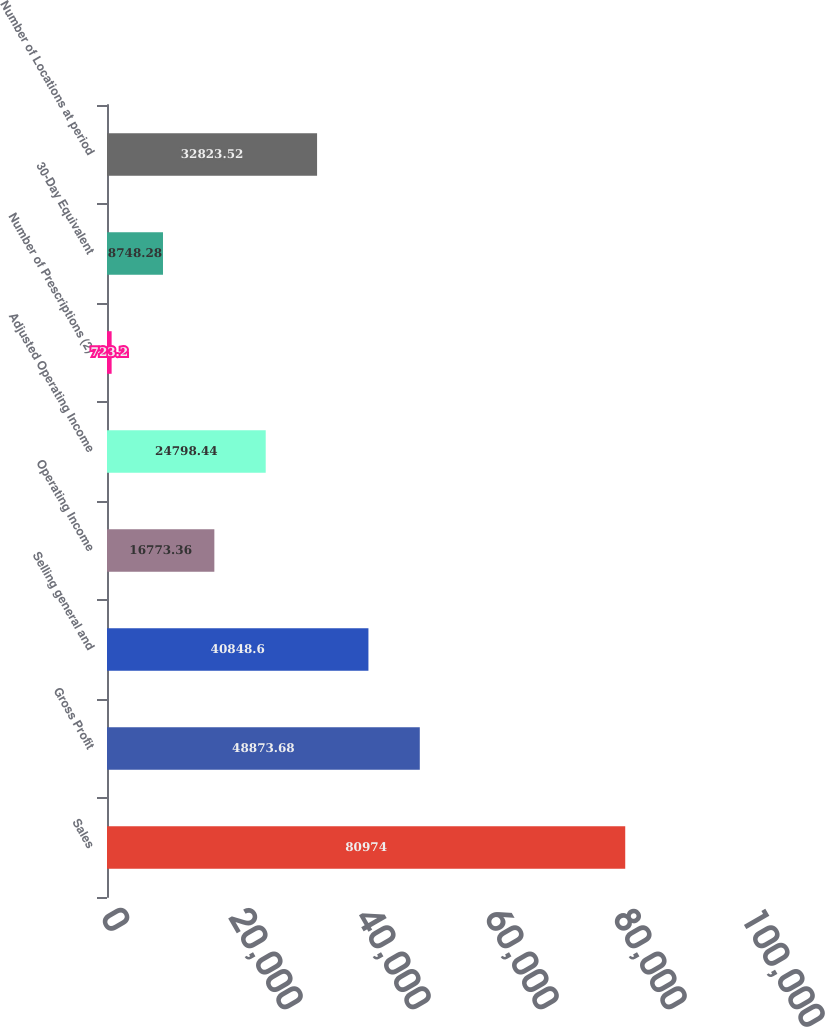Convert chart to OTSL. <chart><loc_0><loc_0><loc_500><loc_500><bar_chart><fcel>Sales<fcel>Gross Profit<fcel>Selling general and<fcel>Operating Income<fcel>Adjusted Operating Income<fcel>Number of Prescriptions (2)<fcel>30-Day Equivalent<fcel>Number of Locations at period<nl><fcel>80974<fcel>48873.7<fcel>40848.6<fcel>16773.4<fcel>24798.4<fcel>723.2<fcel>8748.28<fcel>32823.5<nl></chart> 